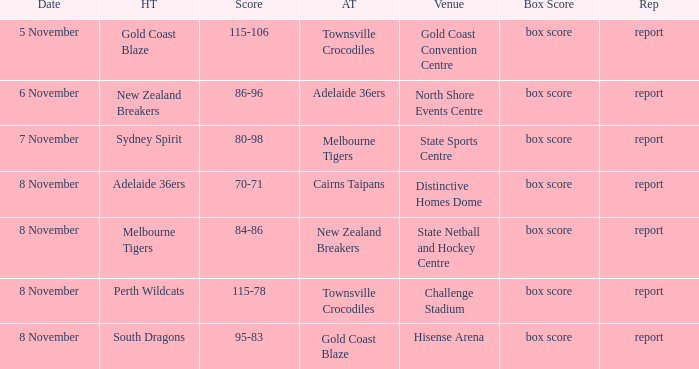Can you give me this table as a dict? {'header': ['Date', 'HT', 'Score', 'AT', 'Venue', 'Box Score', 'Rep'], 'rows': [['5 November', 'Gold Coast Blaze', '115-106', 'Townsville Crocodiles', 'Gold Coast Convention Centre', 'box score', 'report'], ['6 November', 'New Zealand Breakers', '86-96', 'Adelaide 36ers', 'North Shore Events Centre', 'box score', 'report'], ['7 November', 'Sydney Spirit', '80-98', 'Melbourne Tigers', 'State Sports Centre', 'box score', 'report'], ['8 November', 'Adelaide 36ers', '70-71', 'Cairns Taipans', 'Distinctive Homes Dome', 'box score', 'report'], ['8 November', 'Melbourne Tigers', '84-86', 'New Zealand Breakers', 'State Netball and Hockey Centre', 'box score', 'report'], ['8 November', 'Perth Wildcats', '115-78', 'Townsville Crocodiles', 'Challenge Stadium', 'box score', 'report'], ['8 November', 'South Dragons', '95-83', 'Gold Coast Blaze', 'Hisense Arena', 'box score', 'report']]} What was the report at State Sports Centre? Report. 